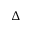Convert formula to latex. <formula><loc_0><loc_0><loc_500><loc_500>\Delta</formula> 